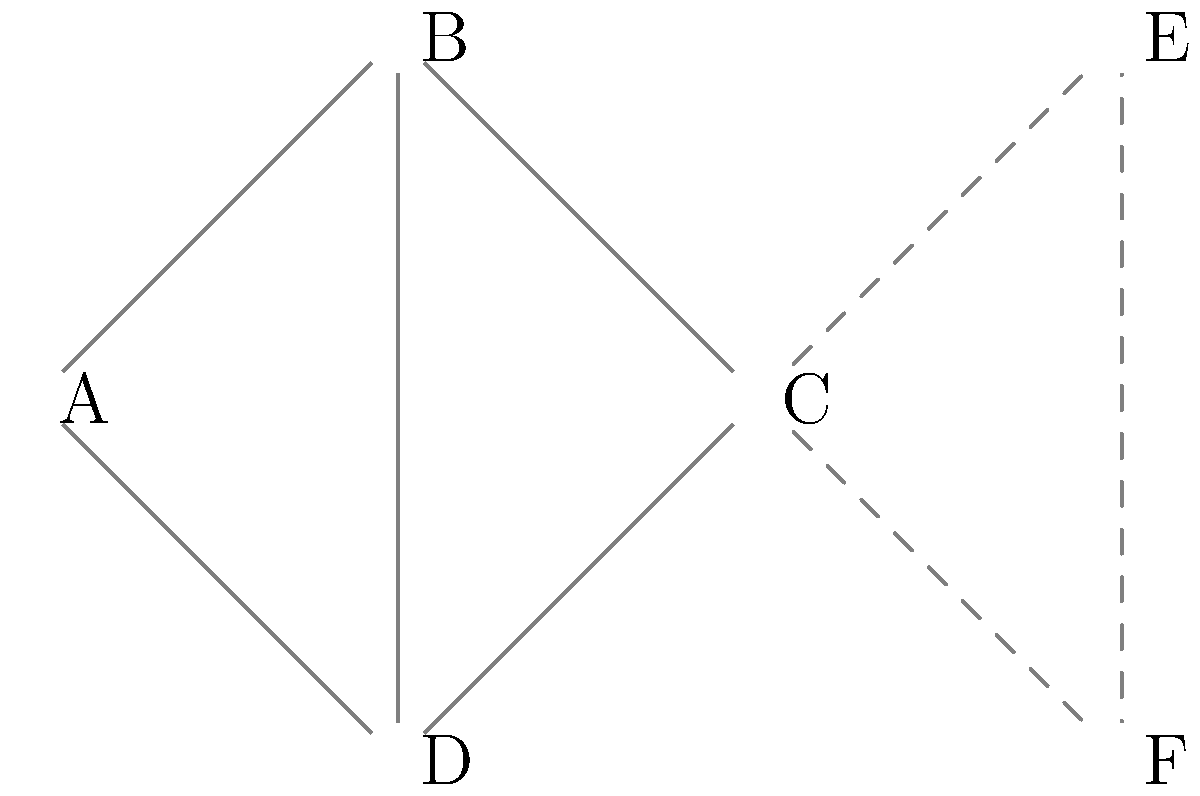In our mesh network project, we're considering adding two new nodes (E and F) connected to node C. How would this change affect the network's resilience, and what would be the new maximum number of node failures the network could tolerate before becoming disconnected? Let's analyze this step-by-step:

1. Current network structure:
   - Nodes: A, B, C, D
   - Connections: A-B, B-C, C-D, D-A, B-D

2. Network resilience before adding E and F:
   - The network can tolerate 1 node failure without becoming disconnected
   - Removing any single node still leaves a path between all other nodes

3. New network structure after adding E and F:
   - Nodes: A, B, C, D, E, F
   - New connections: C-E, E-F, F-C (forming a triangle with C)

4. Improved resilience:
   - The new structure creates redundant paths through E and F
   - Even if C fails, E and F maintain connectivity between the original network and the new nodes

5. Maximum node failures tolerable:
   - The network can now tolerate 2 node failures without becoming disconnected
   - Example: If B and C fail, A-D-F-E still forms a connected path

6. Impact on network performance:
   - Increased redundancy improves fault tolerance
   - Potential for load balancing and reduced network congestion
   - Slightly increased network complexity and management overhead

Therefore, adding nodes E and F significantly improves the network's resilience by increasing the maximum number of tolerable node failures from 1 to 2.
Answer: 2 node failures 